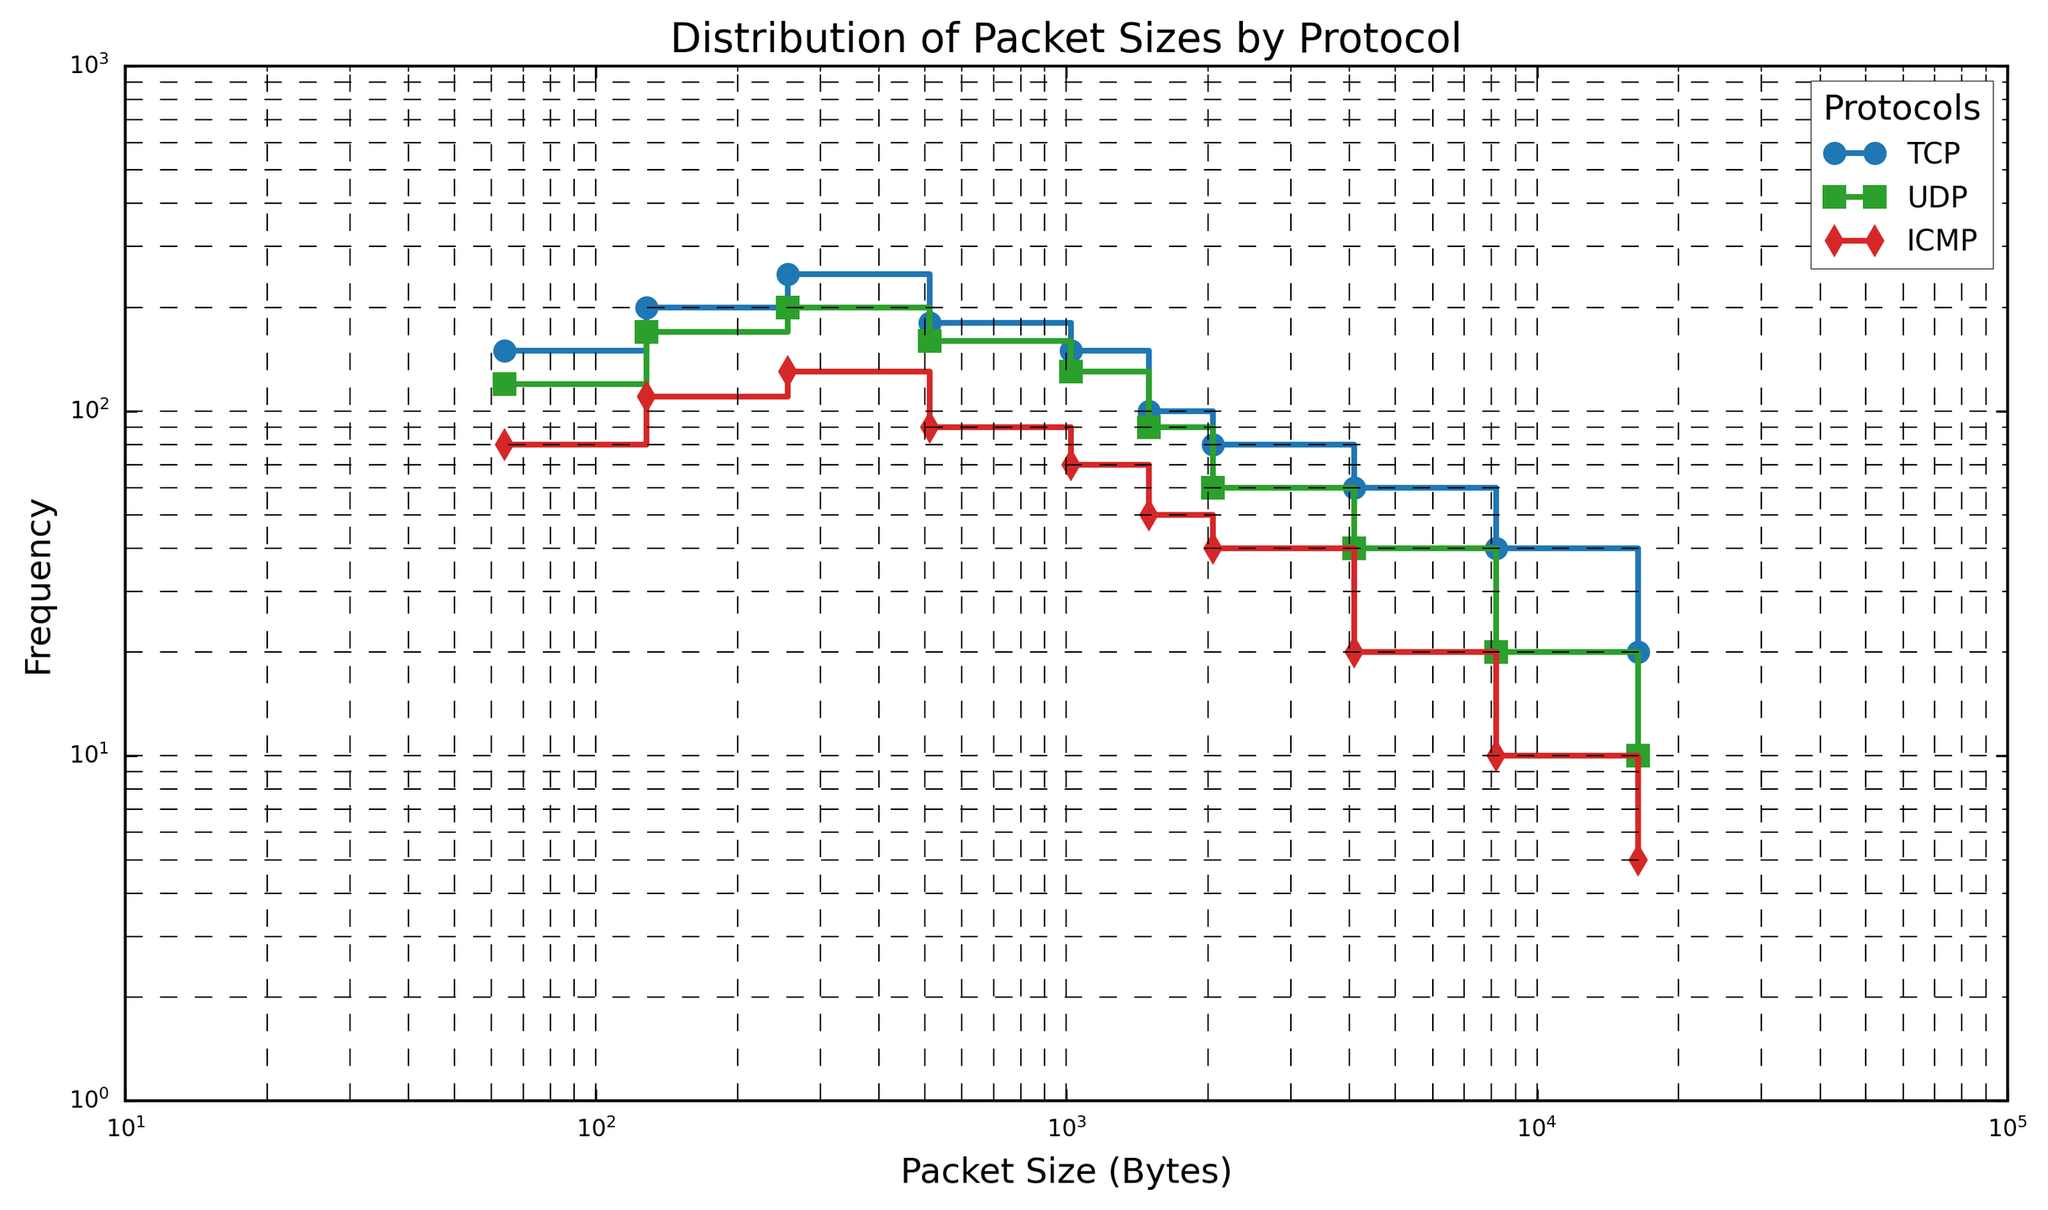Which protocol has the highest frequency at packet size 64 bytes? By examining the first data point for each protocol, the highest value is observed in the TCP line, which is marked with a circle and is visually the highest among the packet sized 64 bytes.
Answer: TCP What is the difference in frequency between TCP and UDP at packet size 128 bytes? At 128 bytes, the frequency for TCP is 200 and for UDP is 170. Subtracting the two values gives 200 - 170 = 30.
Answer: 30 In which packet size range does the frequency of TCP first become equal to the frequency of UDP? By analyzing the patterns, we see that frequencies of UDP and TCP intersect only when the step drops from 150 to 100 in TCP and from 130 to 90 in UDP between the packet sizes 1024 and 1500 bytes.
Answer: Between 1024 and 1500 bytes How does the frequency of ICMP packets compare to those of TCP packets at packet size 4096 bytes? At 4096 bytes, the frequency is 60 for TCP and 20 for ICMP. Clearly, TCP frequency (60) is greater than ICMP frequency (20).
Answer: TCP > ICMP By how much does the frequency of UDP decrease from packet size 128 bytes to 512 bytes? The frequency of UDP is 170 at 128 bytes and 160 at 512 bytes. The decrease is 170 - 160 = 10.
Answer: 10 What color line represents the TCP protocol in the plot? The line representing the TCP protocol is colored blue, which is given by tab:blue in the plotting code.
Answer: Blue For what packet size do the frequencies of all three protocols show a marked decrease compared to the previous sizes? A noticeable decrease across all protocols individually happens between the packet sizes 1500 and 2048 bytes, where each protocol frequency drops significantly.
Answer: Between 1500 and 2048 bytes What is the total frequency of all protocols combined at packet size 256 bytes? Adding the frequencies of TCP (250), UDP (200), and ICMP (130) gives 250 + 200 + 130 = 580.
Answer: 580 